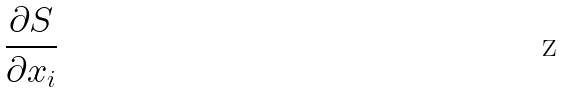Convert formula to latex. <formula><loc_0><loc_0><loc_500><loc_500>\frac { \partial S } { \partial x _ { i } }</formula> 